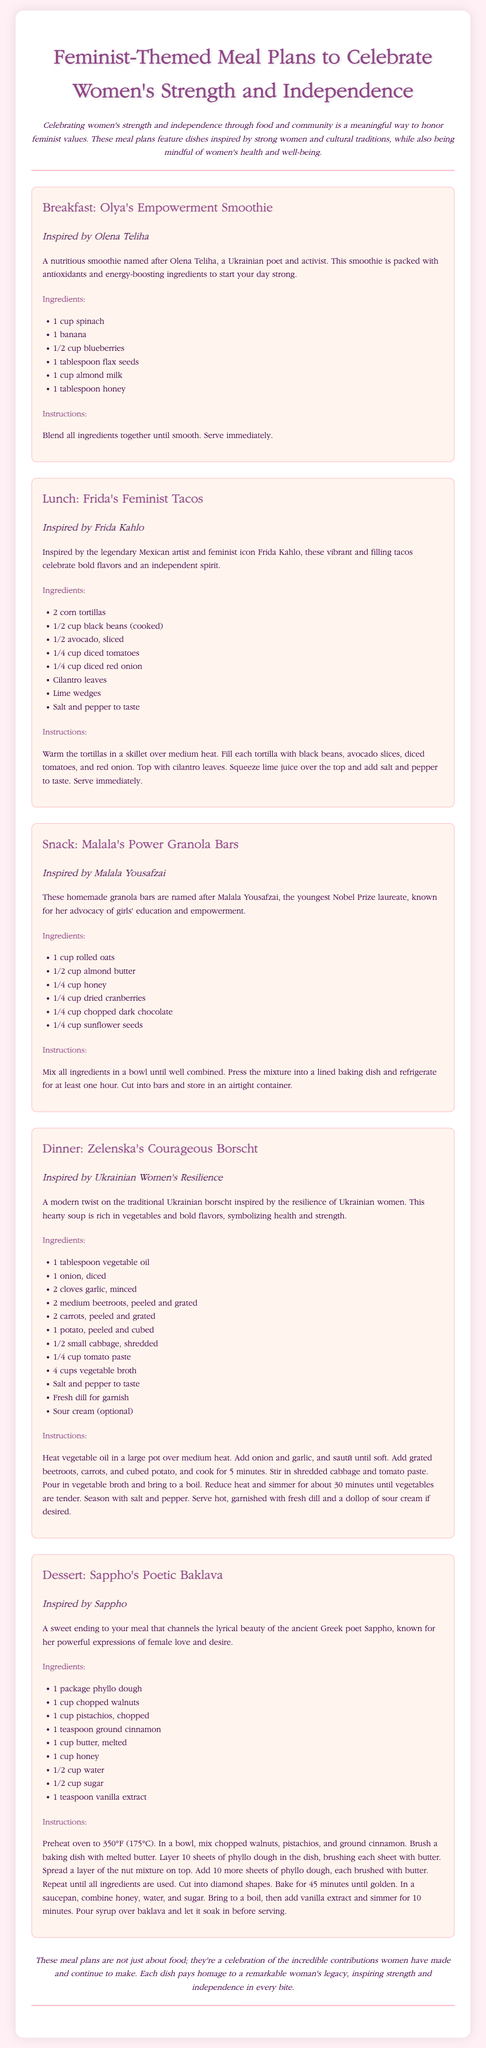what is the title of the document? The title of the document is prominently displayed at the top and indicates the theme of the meal plans.
Answer: Feminist-Themed Meal Plans to Celebrate Women's Strength and Independence who is the inspiration for the breakfast meal? The breakfast meal is named after a notable figure celebrated for her contributions, as stated in the document.
Answer: Olena Teliha what type of meal is Frida's Feminist Tacos? The type of meal reflects the meal structure outlined in the document, distinguishing it from others.
Answer: Lunch how many ingredients are listed for the dinner recipe? The dinner recipe includes a list of items necessary to create the dish, found in the ingredients section.
Answer: 11 what is the main vegetable used in Zelenska's Courageous Borscht? This vegetable is highlighted in the ingredients list and is key to the dish's flavor.
Answer: Beetroot which poet inspired the dessert recipe? The dessert recipe is named in homage to a historical female figure known for her literary influence.
Answer: Sappho what is the purpose of the meal plans according to the conclusion? The conclusion summarizes the essence of the meal plans, emphasizing a communal and celebratory aspect.
Answer: Celebration of contributions how is the power granola bars recipe related to Malala Yousafzai? The connection to Malala Yousafzai is expressed through the name and intent behind the recipe featured in the meal plan.
Answer: Advocacy of girls' education and empowerment 